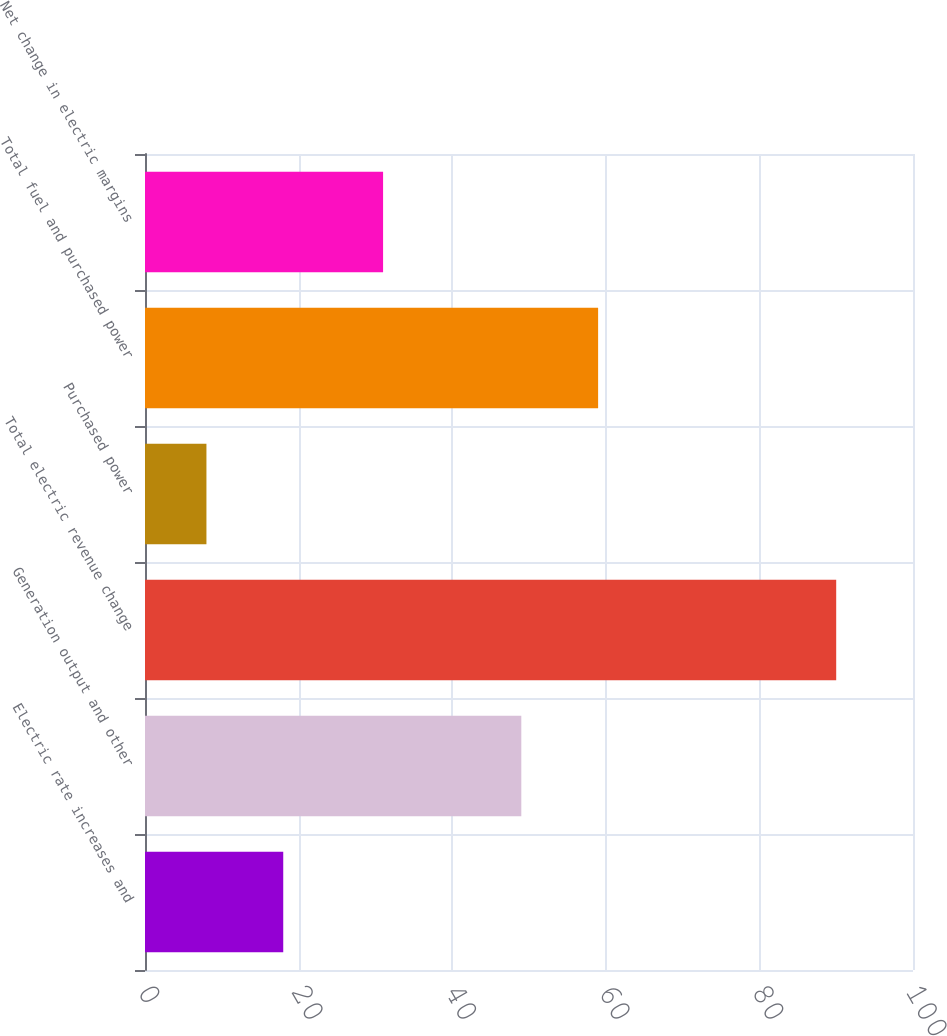<chart> <loc_0><loc_0><loc_500><loc_500><bar_chart><fcel>Electric rate increases and<fcel>Generation output and other<fcel>Total electric revenue change<fcel>Purchased power<fcel>Total fuel and purchased power<fcel>Net change in electric margins<nl><fcel>18<fcel>49<fcel>90<fcel>8<fcel>59<fcel>31<nl></chart> 